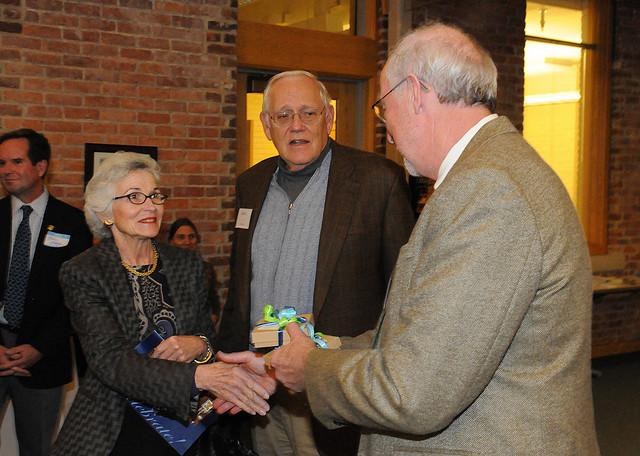Is one of the men bald?
Keep it brief. Yes. IS this a gay wedding?
Answer briefly. No. What is the wall made of?
Answer briefly. Brick. Where is a spot of light shining?
Write a very short answer. Window. Do the people know each other?
Be succinct. Yes. How many people are there?
Answer briefly. 5. 